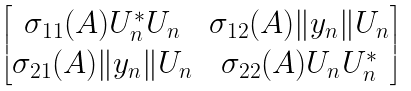<formula> <loc_0><loc_0><loc_500><loc_500>\begin{bmatrix} \sigma _ { 1 1 } ( A ) U _ { n } ^ { * } U _ { n } & \sigma _ { 1 2 } ( A ) \| y _ { n } \| U _ { n } \\ \sigma _ { 2 1 } ( A ) \| y _ { n } \| U _ { n } & \sigma _ { 2 2 } ( A ) U _ { n } U _ { n } ^ { * } \end{bmatrix}</formula> 